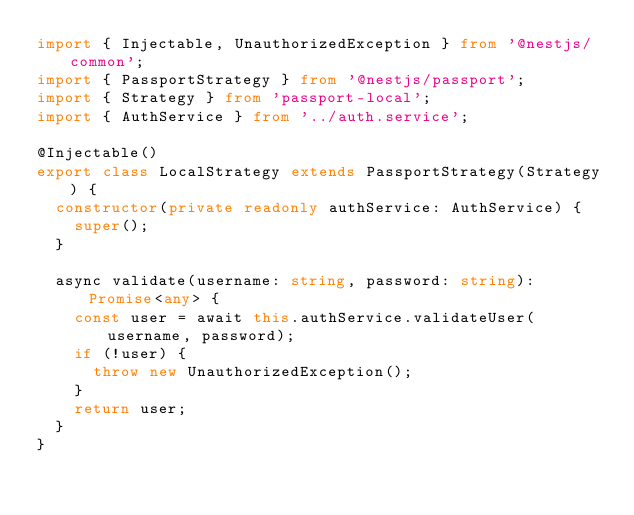Convert code to text. <code><loc_0><loc_0><loc_500><loc_500><_TypeScript_>import { Injectable, UnauthorizedException } from '@nestjs/common';
import { PassportStrategy } from '@nestjs/passport';
import { Strategy } from 'passport-local';
import { AuthService } from '../auth.service';

@Injectable()
export class LocalStrategy extends PassportStrategy(Strategy) {
  constructor(private readonly authService: AuthService) {
    super();
  }

  async validate(username: string, password: string): Promise<any> {
    const user = await this.authService.validateUser(username, password);
    if (!user) {
      throw new UnauthorizedException();
    }
    return user;
  }
}
</code> 